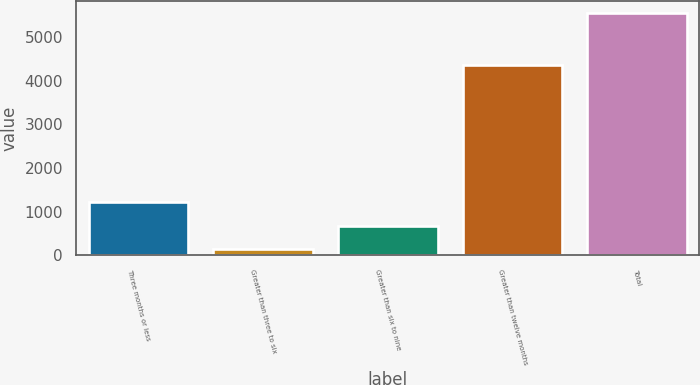Convert chart to OTSL. <chart><loc_0><loc_0><loc_500><loc_500><bar_chart><fcel>Three months or less<fcel>Greater than three to six<fcel>Greater than six to nine<fcel>Greater than twelve months<fcel>Total<nl><fcel>1217.8<fcel>136<fcel>676.9<fcel>4361<fcel>5545<nl></chart> 